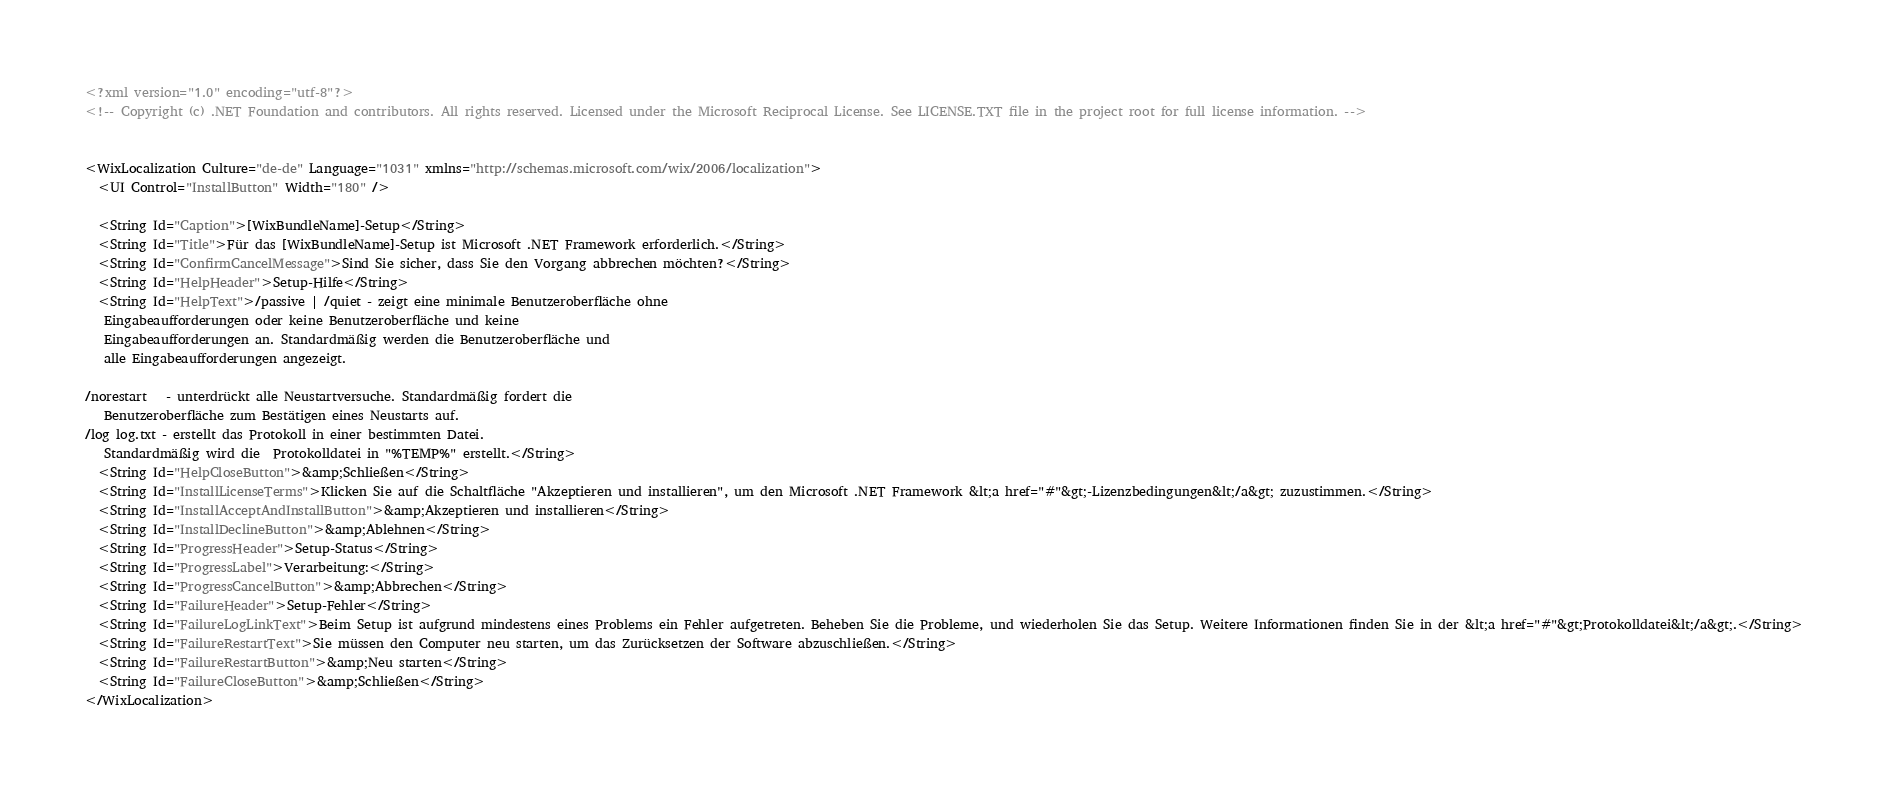<code> <loc_0><loc_0><loc_500><loc_500><_XML_><?xml version="1.0" encoding="utf-8"?>
<!-- Copyright (c) .NET Foundation and contributors. All rights reserved. Licensed under the Microsoft Reciprocal License. See LICENSE.TXT file in the project root for full license information. -->


<WixLocalization Culture="de-de" Language="1031" xmlns="http://schemas.microsoft.com/wix/2006/localization">
  <UI Control="InstallButton" Width="180" />
  
  <String Id="Caption">[WixBundleName]-Setup</String>
  <String Id="Title">Für das [WixBundleName]-Setup ist Microsoft .NET Framework erforderlich.</String>
  <String Id="ConfirmCancelMessage">Sind Sie sicher, dass Sie den Vorgang abbrechen möchten?</String>
  <String Id="HelpHeader">Setup-Hilfe</String>
  <String Id="HelpText">/passive | /quiet - zeigt eine minimale Benutzeroberfläche ohne
   Eingabeaufforderungen oder keine Benutzeroberfläche und keine
   Eingabeaufforderungen an. Standardmäßig werden die Benutzeroberfläche und
   alle Eingabeaufforderungen angezeigt.

/norestart   - unterdrückt alle Neustartversuche. Standardmäßig fordert die
   Benutzeroberfläche zum Bestätigen eines Neustarts auf.
/log log.txt - erstellt das Protokoll in einer bestimmten Datei.
   Standardmäßig wird die  Protokolldatei in "%TEMP%" erstellt.</String>
  <String Id="HelpCloseButton">&amp;Schließen</String>
  <String Id="InstallLicenseTerms">Klicken Sie auf die Schaltfläche "Akzeptieren und installieren", um den Microsoft .NET Framework &lt;a href="#"&gt;-Lizenzbedingungen&lt;/a&gt; zuzustimmen.</String>
  <String Id="InstallAcceptAndInstallButton">&amp;Akzeptieren und installieren</String>
  <String Id="InstallDeclineButton">&amp;Ablehnen</String>
  <String Id="ProgressHeader">Setup-Status</String>
  <String Id="ProgressLabel">Verarbeitung:</String>
  <String Id="ProgressCancelButton">&amp;Abbrechen</String>
  <String Id="FailureHeader">Setup-Fehler</String>
  <String Id="FailureLogLinkText">Beim Setup ist aufgrund mindestens eines Problems ein Fehler aufgetreten. Beheben Sie die Probleme, und wiederholen Sie das Setup. Weitere Informationen finden Sie in der &lt;a href="#"&gt;Protokolldatei&lt;/a&gt;.</String>
  <String Id="FailureRestartText">Sie müssen den Computer neu starten, um das Zurücksetzen der Software abzuschließen.</String>
  <String Id="FailureRestartButton">&amp;Neu starten</String>
  <String Id="FailureCloseButton">&amp;Schließen</String>
</WixLocalization>
</code> 